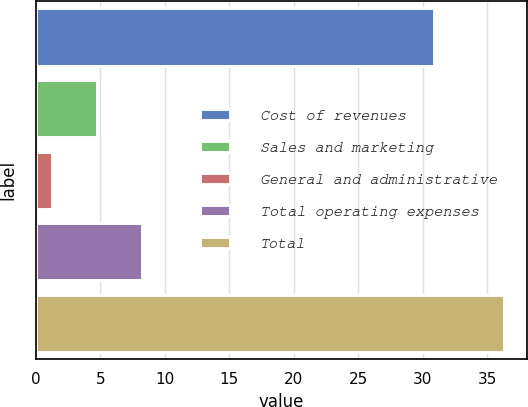Convert chart. <chart><loc_0><loc_0><loc_500><loc_500><bar_chart><fcel>Cost of revenues<fcel>Sales and marketing<fcel>General and administrative<fcel>Total operating expenses<fcel>Total<nl><fcel>30.9<fcel>4.71<fcel>1.2<fcel>8.22<fcel>36.3<nl></chart> 